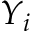<formula> <loc_0><loc_0><loc_500><loc_500>Y _ { i }</formula> 